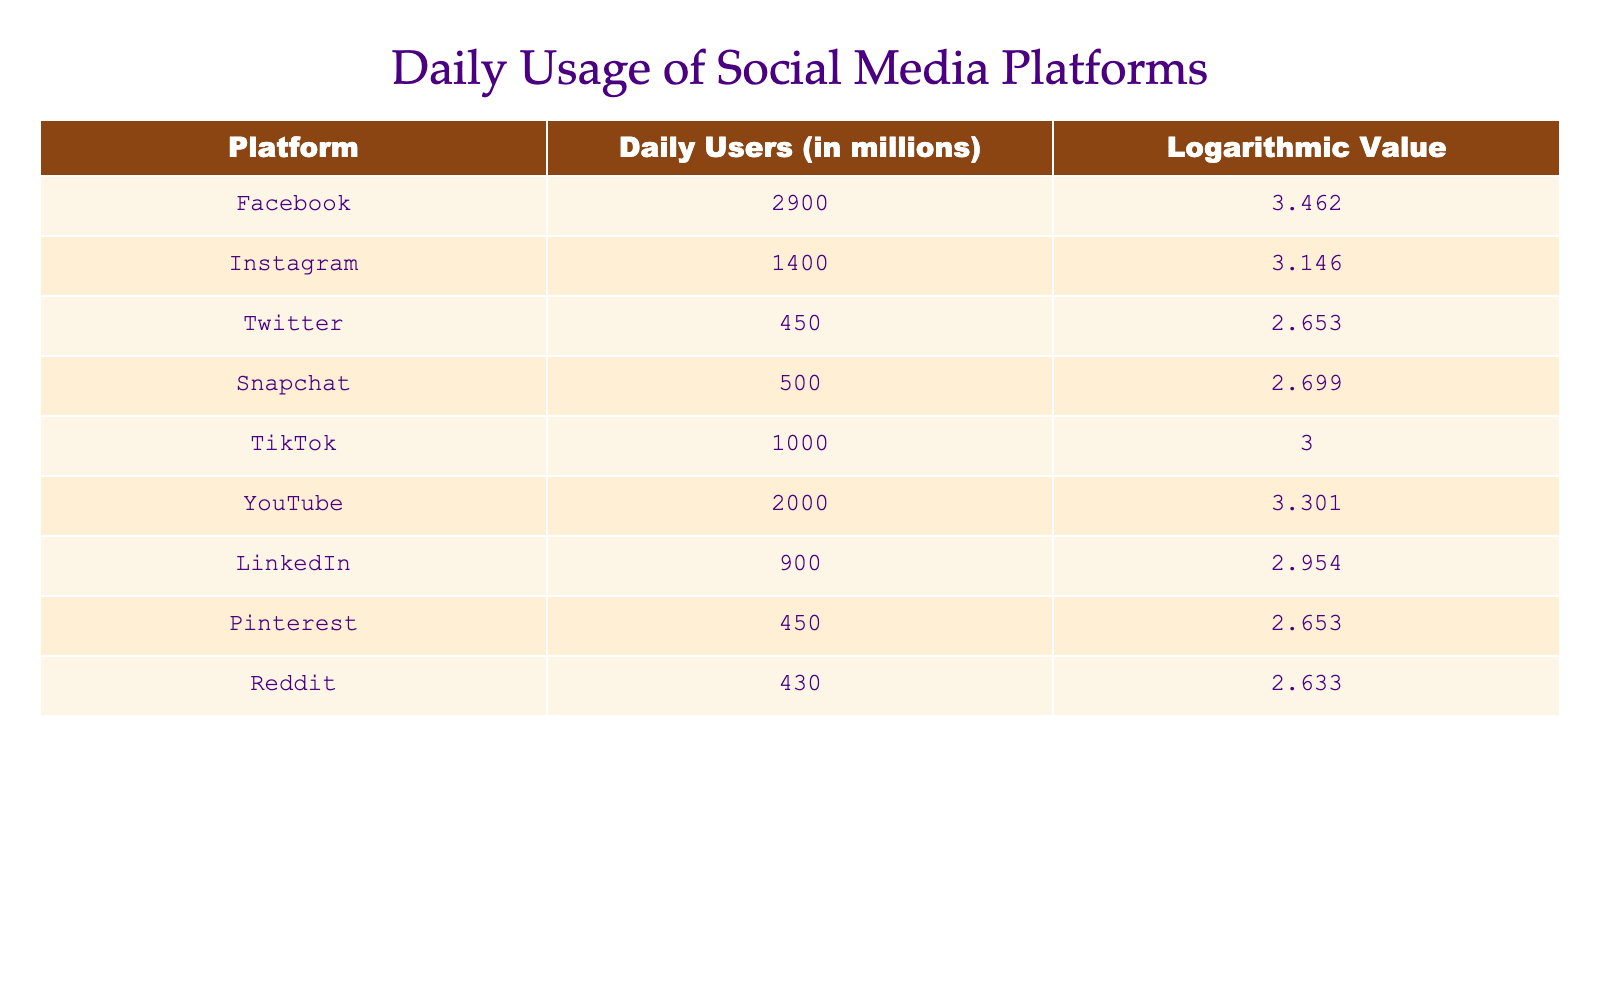What is the logarithmic value for Twitter? The table lists the logarithmic values for each platform, and for Twitter, the value provided is 2.653.
Answer: 2.653 Which platform has the highest number of daily users? By comparing the "Daily Users" column, Facebook has the highest value with 2900 million users.
Answer: Facebook What is the total number of daily users for Instagram and TikTok combined? The daily users for Instagram are 1400 million and for TikTok, it is 1000 million. Adding these together gives 1400 + 1000 = 2400 million.
Answer: 2400 million Is it true that there are more users on YouTube than on Snapchat? The daily users for YouTube are 2000 million while Snapchat has 500 million. Since 2000 is greater than 500, the statement is true.
Answer: Yes What is the difference in daily users between Pinterest and Reddit? Pinterest has 450 million daily users and Reddit has 430 million. The difference is 450 - 430 = 20 million.
Answer: 20 million What is the average daily number of users for all platforms listed? First, sum up all the daily users: 2900 + 1400 + 450 + 500 + 1000 + 2000 + 900 + 450 + 430 = 9150 million. There are 9 platforms, so the average is 9150 / 9 = 1016.67 million.
Answer: Approximately 1016.67 million Which platform has a logarithmic value closest to 3.0 but is below it? By examining the logarithmic values, Snapchat has a value of 2.699, which is less than 3.0 and closest to it after TikTok.
Answer: Snapchat How many platforms have more than 1000 million daily users? The platforms with more than 1000 million users are Facebook (2900), YouTube (2000), and Instagram (1400). Counting these gives a total of 3 platforms.
Answer: 3 platforms Which platform has the logarithmic value of 3.301? The table shows that YouTube has a logarithmic value of 3.301.
Answer: YouTube 